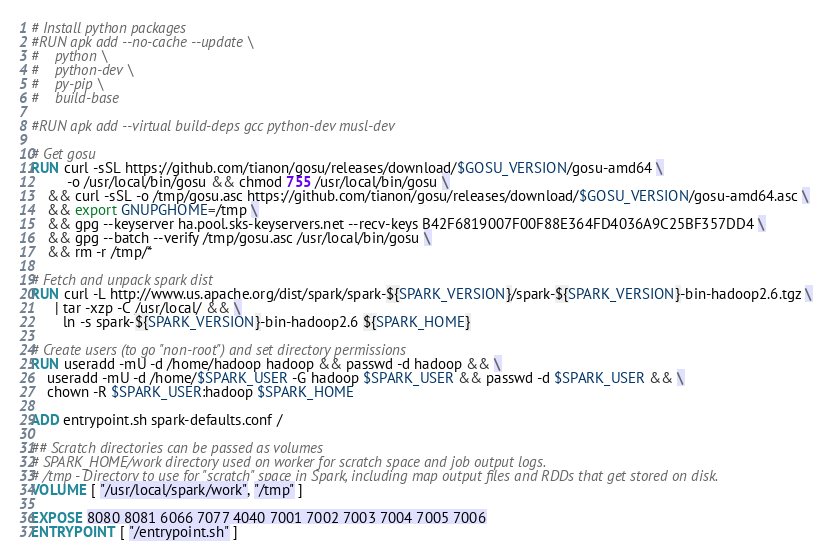Convert code to text. <code><loc_0><loc_0><loc_500><loc_500><_Dockerfile_>
# Install python packages
#RUN apk add --no-cache --update \
#    python \
#    python-dev \
#    py-pip \
#    build-base

#RUN apk add --virtual build-deps gcc python-dev musl-dev

# Get gosu
RUN curl -sSL https://github.com/tianon/gosu/releases/download/$GOSU_VERSION/gosu-amd64 \
         -o /usr/local/bin/gosu && chmod 755 /usr/local/bin/gosu \
    && curl -sSL -o /tmp/gosu.asc https://github.com/tianon/gosu/releases/download/$GOSU_VERSION/gosu-amd64.asc \
    && export GNUPGHOME=/tmp \
    && gpg --keyserver ha.pool.sks-keyservers.net --recv-keys B42F6819007F00F88E364FD4036A9C25BF357DD4 \
    && gpg --batch --verify /tmp/gosu.asc /usr/local/bin/gosu \
    && rm -r /tmp/* 

# Fetch and unpack spark dist
RUN curl -L http://www.us.apache.org/dist/spark/spark-${SPARK_VERSION}/spark-${SPARK_VERSION}-bin-hadoop2.6.tgz \
      | tar -xzp -C /usr/local/ && \
        ln -s spark-${SPARK_VERSION}-bin-hadoop2.6 ${SPARK_HOME}

# Create users (to go "non-root") and set directory permissions
RUN useradd -mU -d /home/hadoop hadoop && passwd -d hadoop && \
    useradd -mU -d /home/$SPARK_USER -G hadoop $SPARK_USER && passwd -d $SPARK_USER && \
    chown -R $SPARK_USER:hadoop $SPARK_HOME

ADD entrypoint.sh spark-defaults.conf /

## Scratch directories can be passed as volumes
# SPARK_HOME/work directory used on worker for scratch space and job output logs.
# /tmp - Directory to use for "scratch" space in Spark, including map output files and RDDs that get stored on disk.
VOLUME [ "/usr/local/spark/work", "/tmp" ]

EXPOSE 8080 8081 6066 7077 4040 7001 7002 7003 7004 7005 7006
ENTRYPOINT [ "/entrypoint.sh" ]
</code> 